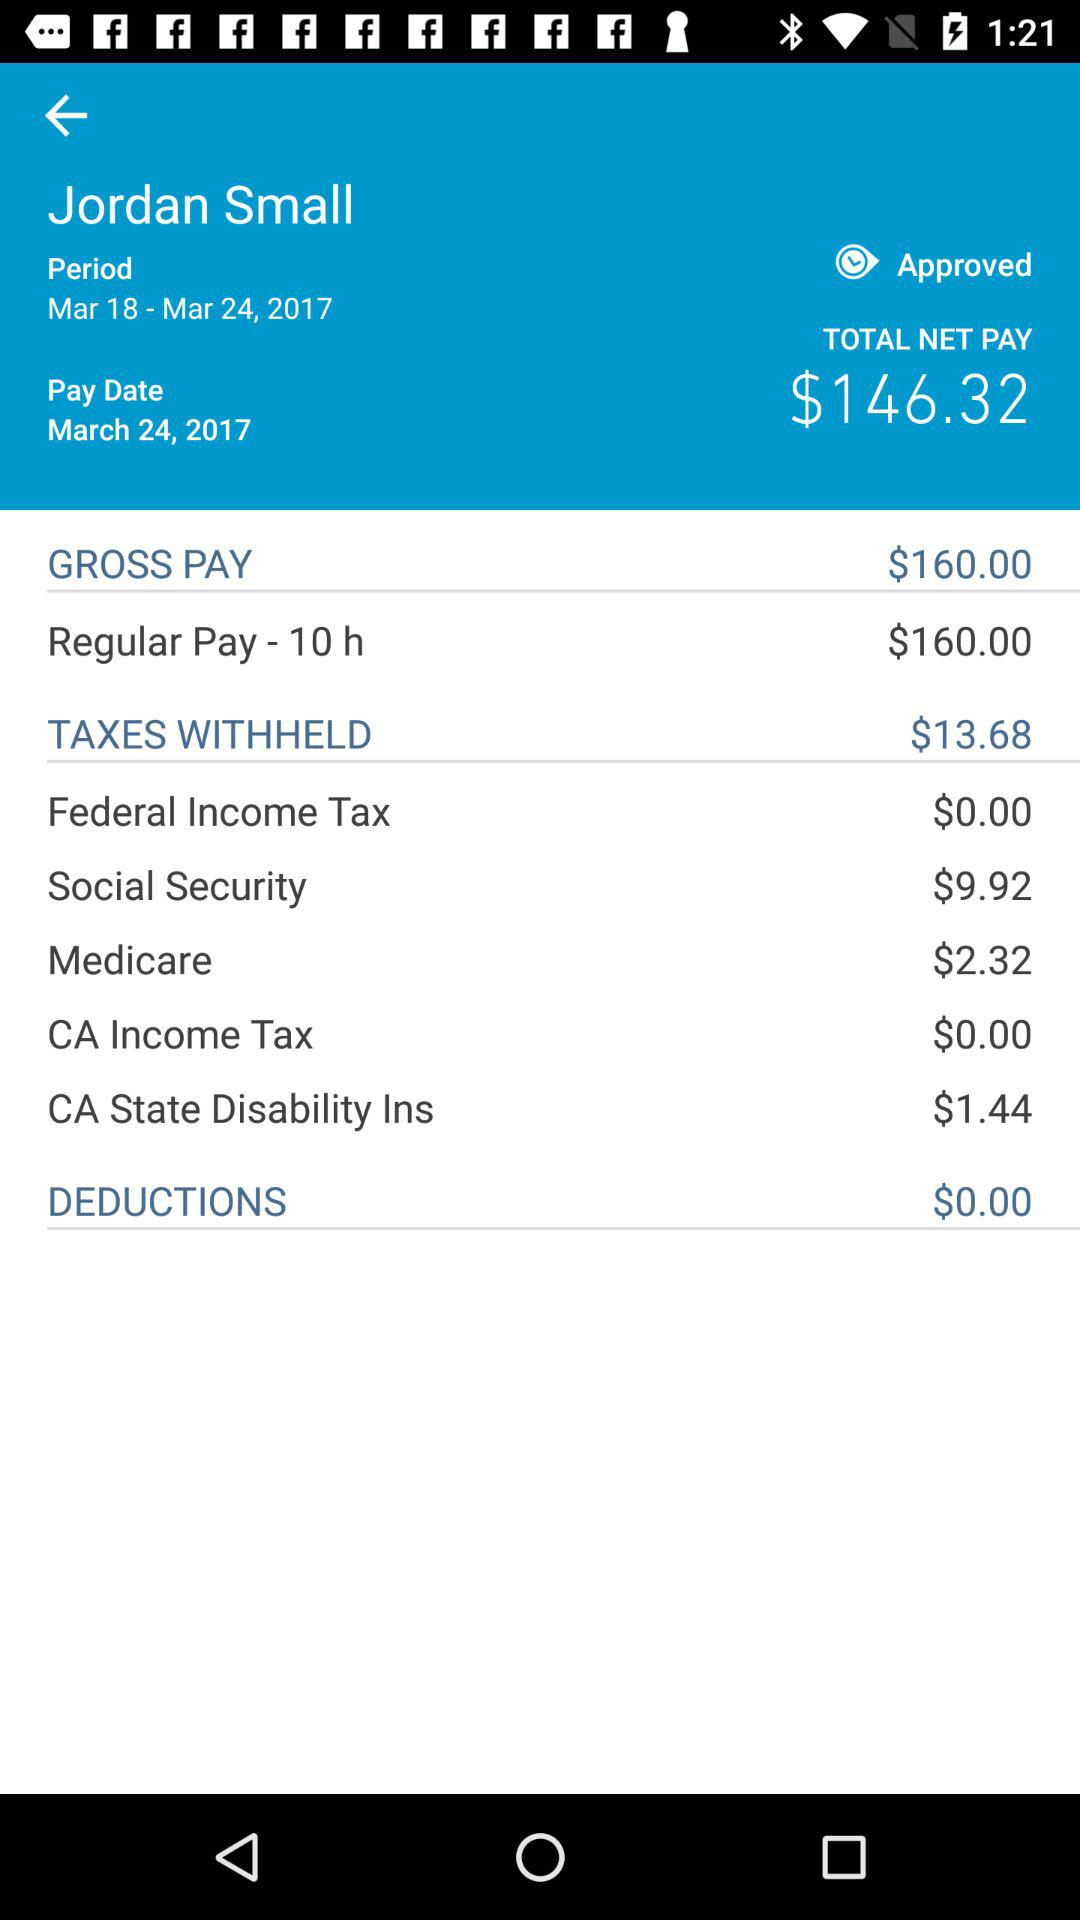How much is the total net pay? The total net pay is $146.32. 